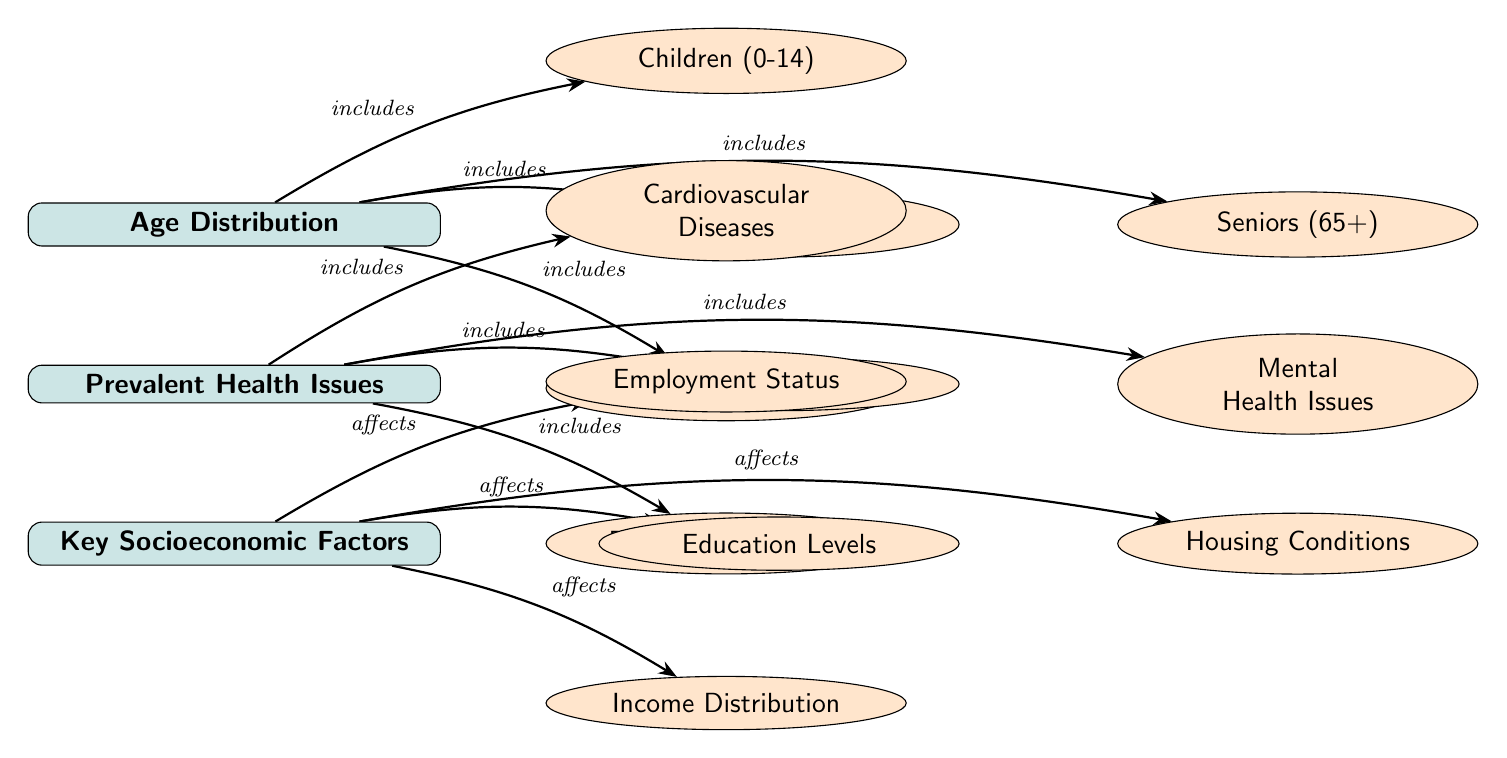What are the four main age categories represented in the diagram? The diagram lists the age categories as Children (0-14), Youth (15-24), Adults (25-64), and Seniors (65+). This can be found directly under the "Age Distribution" node as sub-nodes.
Answer: Children (0-14), Youth (15-24), Adults (25-64), Seniors (65+) How many prevalent health issues are identified in the diagram? There are four prevalent health issues indicated as sub-nodes under the "Prevalent Health Issues" node: Cardiovascular Diseases, Diabetes, Respiratory Diseases, and Mental Health Issues. This count can be derived from how many sub-nodes are connected to the health node.
Answer: Four Which socioeconomic factor is associated with housing conditions? Housing Conditions is a sub-node under Key Socioeconomic Factors. It is positioned to the right of the Education Levels sub-node and below the Employment Status sub-node, indicating its association within the diagram.
Answer: Housing Conditions What relationship is labeled between healthcare issues and the age distribution? Although there is no direct labeling of a relationship between "Prevalent Health Issues" and "Age Distribution," one can infer a potential impact since various age groups may experience different health issues. However, this detail is not explicitly stated in the diagram. The inquiry about the health issues' connection comes under the reasoning questions.
Answer: Not explicitly stated What affects the Key Socioeconomic Factors according to the diagram? The diagram indicates that Employment Status, Education Levels, Income Distribution, and Housing Conditions are all affected by Key Socioeconomic Factors. Each sub-node is interconnected as a consequence of socioeconomic influences.
Answer: Affects Discuss the flow of influence from Age Distribution to Prevalent Health Issues. What kind of reasoning connects them? The diagram shows a hierarchical structure where the Age Distribution influences the type of health issues prevalent in different age groups. For instance, children might face different health challenges than seniors. This reasoning requires an understanding of how age can impact health concerns which is not directly labeled but logically inferred from the diagram's arrangement.
Answer: Flow inferred, not explicitly stated How many different types of socioeconomic factors are represented in the diagram? The diagram includes four different types of socioeconomic factors identified as Employment Status, Education Levels, Income Distribution, and Housing Conditions. Each of these is a sub-node stemming from the Key Socioeconomic Factors main node.
Answer: Four Which health issue is directly next to Diabetes? The health issue directly to the right of Diabetes is Mental Health Issues. The diagram arranges these elements in a horizontal manner, making it easy to determine adjacency.
Answer: Mental Health Issues What does the diagram imply about the relationship between age groups and health issues? The diagram layout implies that there is a connection between the age distribution and the types of health issues, suggesting that certain age groups may be more susceptible to specific health conditions. This is understood from the way the two sets of nodes are structured hierarchically.
Answer: Implicit connection 